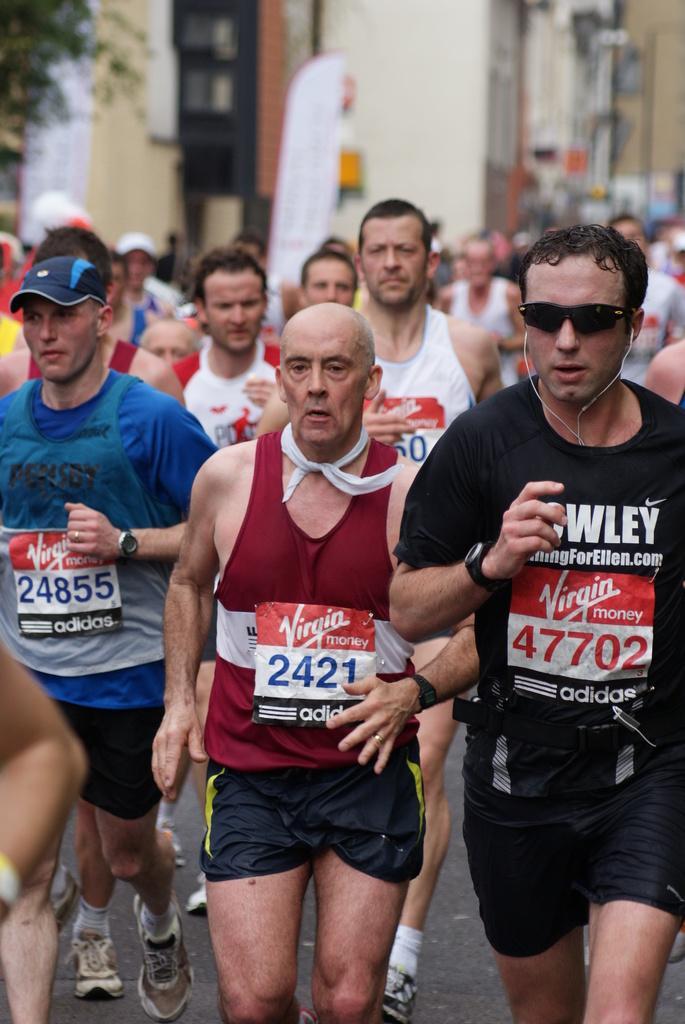Could you give a brief overview of what you see in this image? In the image there are many people running. On the right corner of the image there is a man with goggles and headset. And on the left corner of the image there is a man with a cap on his head. There is a blur background with trees, buildings and poles. 